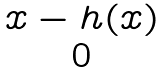<formula> <loc_0><loc_0><loc_500><loc_500>\begin{matrix} x - h ( x ) \\ 0 \end{matrix}</formula> 